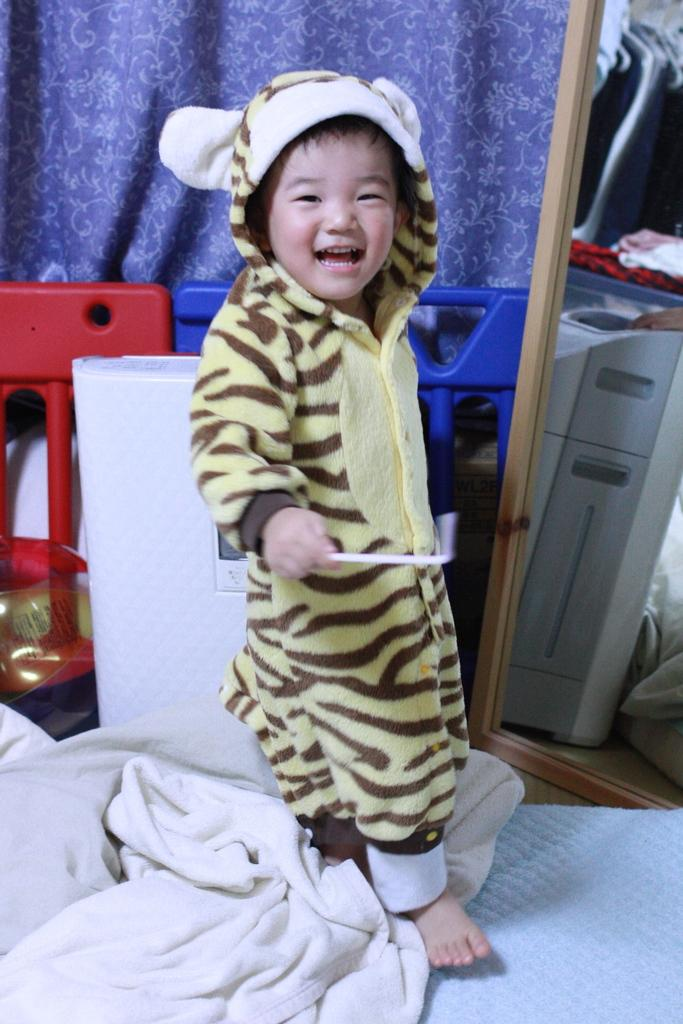What is the main subject of the image? The main subject of the image is a kid. What is the kid's expression in the image? The kid is smiling in the image. What can be seen beside the kid? There is a machine beside the kid. What type of window treatment is present in the image? There are curtains in the image. What is the historical significance of the scent in the image? There is no mention of a scent in the image, so it is not possible to discuss its historical significance. 